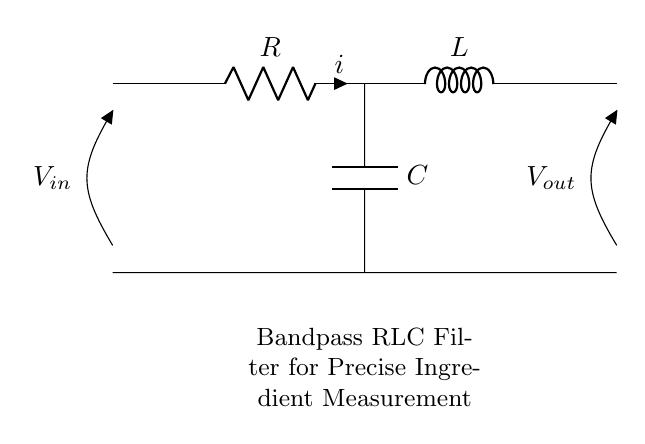What are the components in this circuit? The circuit contains a resistor, inductor, and capacitor, which are standard components in an RLC circuit. These components are specifically labeled in the diagram, confirming their presence.
Answer: Resistor, inductor, capacitor What is the configuration of the circuit? The components are arranged in series, where the resistor connects to the inductor, and the inductor connects to the capacitor, showing a typical series arrangement for such circuits.
Answer: Series What is the purpose of the circuit? The purpose of this bandpass RLC filter is to filter specific frequencies, allowing precise measurements of ingredients in electronic scales. This is indicated by the label below the circuit diagram.
Answer: Bandpass filtering What is the role of the resistor in this circuit? The resistor limits the current flow and affects the damping of the circuit, which is essential in controlling the output signal and its quality in the bandpass filter.
Answer: Current limiting and damping What happens if the inductor is removed from the circuit? Removing the inductor would eliminate the characteristics of a bandpass filter, as the circuit would no longer have the necessary reactive properties to filter certain frequencies effectively.
Answer: Loss of filtering What is the relationship between input and output voltage in this type of circuit? In a bandpass RLC circuit, the output voltage is maximized at the resonant frequency, which allows for efficient signal transmission. This relationship is defined by the reactive components creating resonant behavior.
Answer: Resonant frequency amplification What would be the effect of increasing the capacitance in this circuit? Increasing capacitance would lower the resonant frequency of the RLC circuit, allowing it to pass lower frequency signals while blocking higher frequencies, thus changing its filtering characteristics.
Answer: Lower resonant frequency 